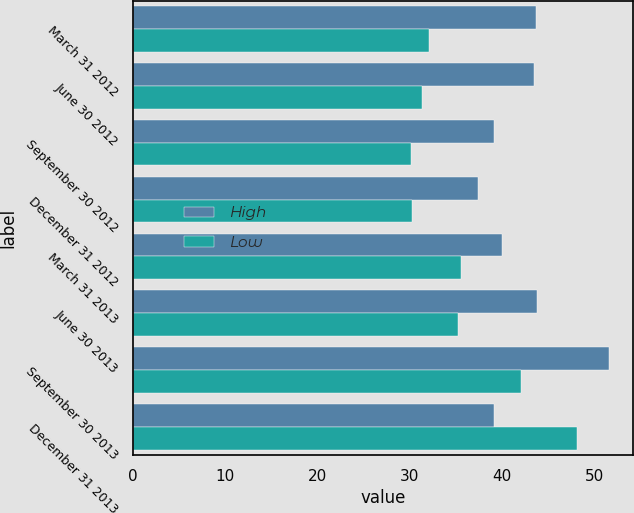Convert chart to OTSL. <chart><loc_0><loc_0><loc_500><loc_500><stacked_bar_chart><ecel><fcel>March 31 2012<fcel>June 30 2012<fcel>September 30 2012<fcel>December 31 2012<fcel>March 31 2013<fcel>June 30 2013<fcel>September 30 2013<fcel>December 31 2013<nl><fcel>High<fcel>43.73<fcel>43.5<fcel>39.09<fcel>37.44<fcel>40.05<fcel>43.83<fcel>51.63<fcel>39.09<nl><fcel>Low<fcel>32.14<fcel>31.31<fcel>30.09<fcel>30.27<fcel>35.51<fcel>35.22<fcel>42.07<fcel>48.13<nl></chart> 